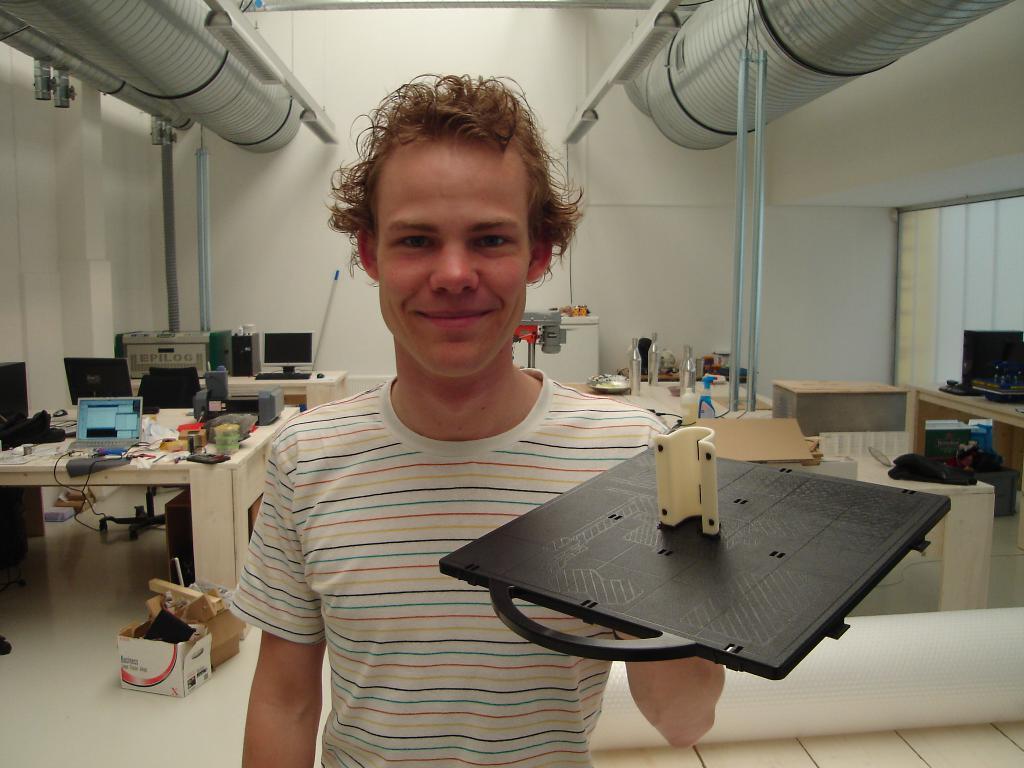Can you describe this image briefly? This is the man standing and smiling. He is holding an object in his hand. This is a table with a laptop, printer, papers and few other objects on it. I can see a monitor, keyboard, CPU and some other machines placed on another table. These are the pipes and tube lights attached to the roof. I can see another table with bottles and few other things. This looks like a sheet, which is white in color. These are the cardboard boxes with few things in it. This looks like a window. 